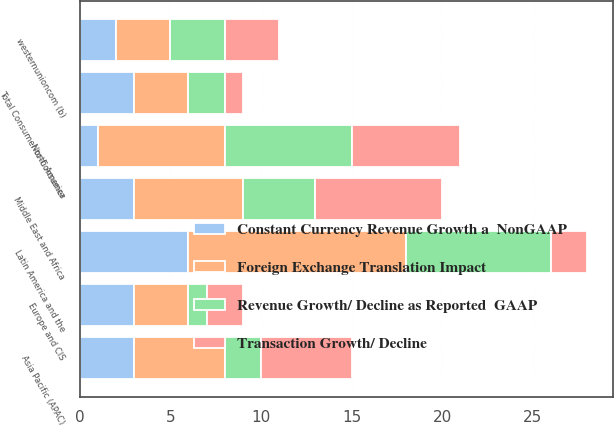Convert chart. <chart><loc_0><loc_0><loc_500><loc_500><stacked_bar_chart><ecel><fcel>North America<fcel>Europe and CIS<fcel>Middle East and Africa<fcel>Asia Pacific (APAC)<fcel>Latin America and the<fcel>Total Consumer-to-Consumer<fcel>westernunioncom (b)<nl><fcel>Transaction Growth/ Decline<fcel>6<fcel>2<fcel>7<fcel>5<fcel>2<fcel>1<fcel>3<nl><fcel>Constant Currency Revenue Growth a  NonGAAP<fcel>1<fcel>3<fcel>3<fcel>3<fcel>6<fcel>3<fcel>2<nl><fcel>Revenue Growth/ Decline as Reported  GAAP<fcel>7<fcel>1<fcel>4<fcel>2<fcel>8<fcel>2<fcel>3<nl><fcel>Foreign Exchange Translation Impact<fcel>7<fcel>3<fcel>6<fcel>5<fcel>12<fcel>3<fcel>3<nl></chart> 